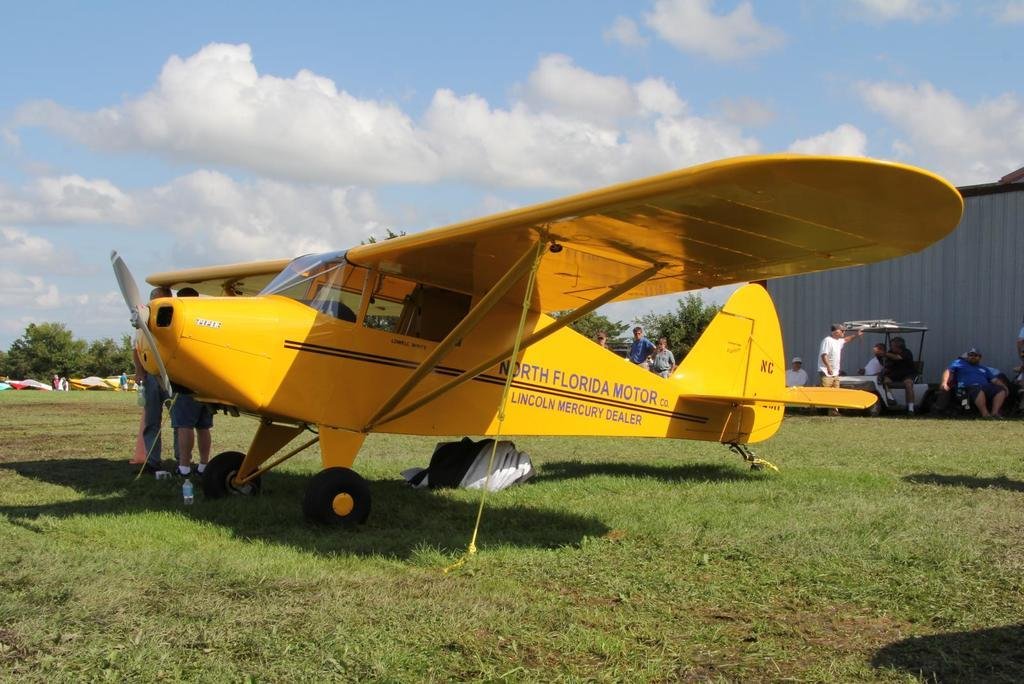<image>
Offer a succinct explanation of the picture presented. A yellow airplane made by North Florida Motor Co. 